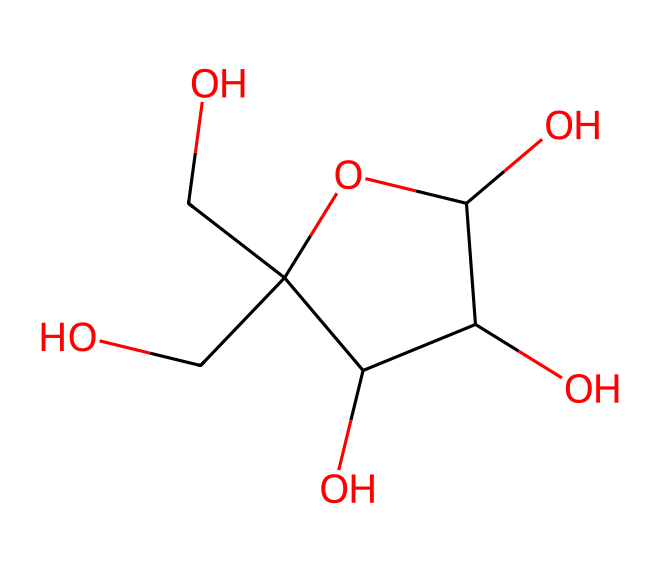How many carbon atoms are in fructose? The SMILES representation shows that there are five carbon atoms (indicated by "C") present in the structure of fructose.
Answer: five What is the molecular structure type of fructose? Fructose falls under the category of monosaccharides, which are simple sugars characterized by their basic chemical structure of carbon, hydrogen, and oxygen, specifically in the arrangement found in the SMILES.
Answer: monosaccharide How many hydroxyl (OH) groups are there in fructose? By analyzing the structure, we can identify the hydroxyl groups (–OH) present; there are four hydroxyl groups in the fructose structure.
Answer: four Which type of carbohydrate is represented by this chemical? The chemical structure, being a simple sugar, classifies fructose as a ketose carbohydrate due to the arrangement of its carbonyl group.
Answer: ketose What is the total number of hydrogen atoms in fructose? To determine the total number of hydrogen atoms, count the hydrogen atoms shown in the structure. In fructose, there are ten hydrogen atoms present.
Answer: ten Why is fructose considered sweeter than glucose? Fructose has a unique molecular configuration that allows it to bind to sweetness receptors on our taste buds more effectively than glucose, making it perceived as sweeter.
Answer: sweeter How many rings are present in the structure of fructose? Analyzing the SMILES representation reveals that fructose contains one stable ring structure formed by its five carbon atoms, indicating that it is in a cyclic form.
Answer: one 